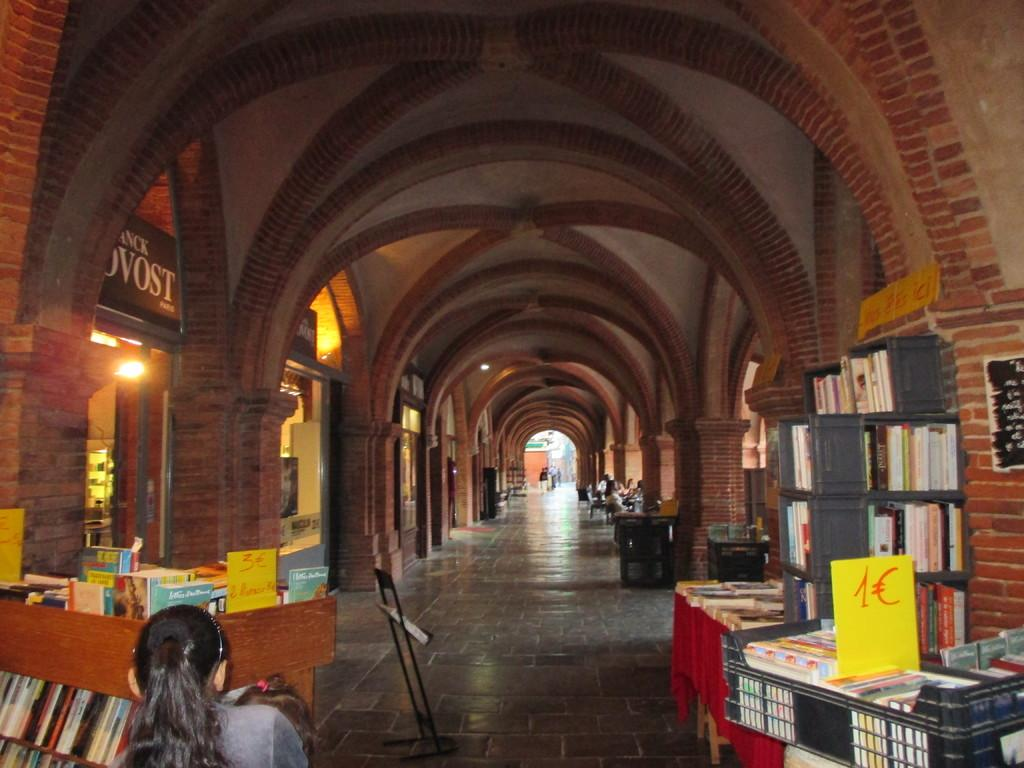<image>
Provide a brief description of the given image. a book sale in a large room has a table for 1 and 3 ampunts of money 